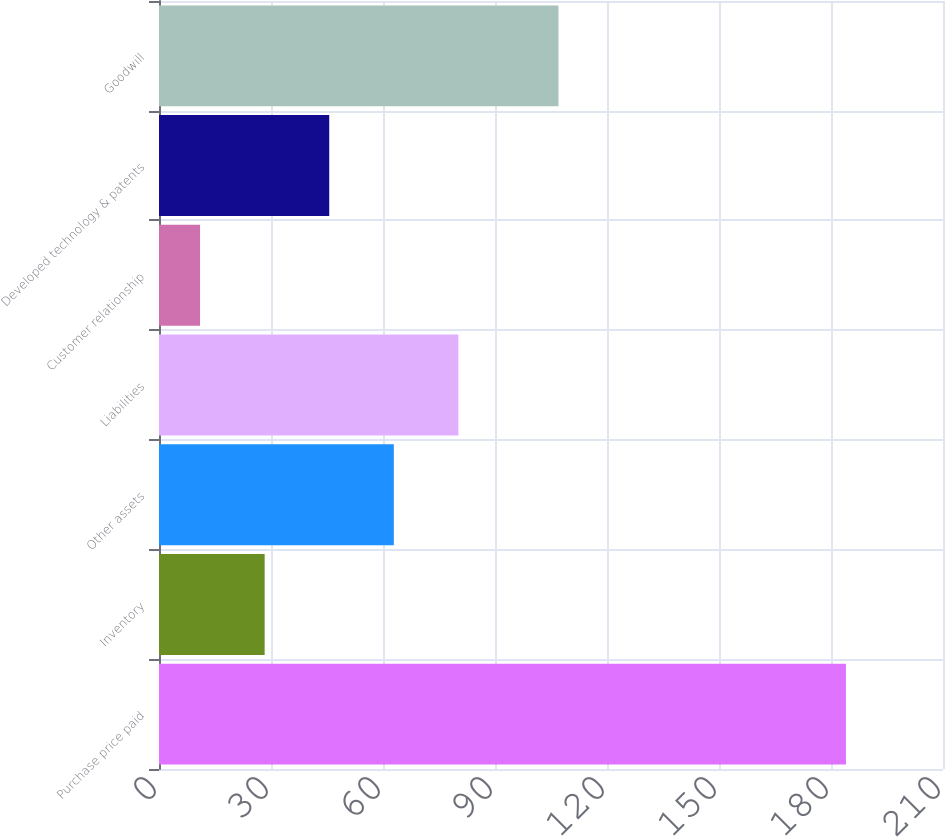<chart> <loc_0><loc_0><loc_500><loc_500><bar_chart><fcel>Purchase price paid<fcel>Inventory<fcel>Other assets<fcel>Liabilities<fcel>Customer relationship<fcel>Developed technology & patents<fcel>Goodwill<nl><fcel>184<fcel>28.3<fcel>62.9<fcel>80.2<fcel>11<fcel>45.6<fcel>107<nl></chart> 